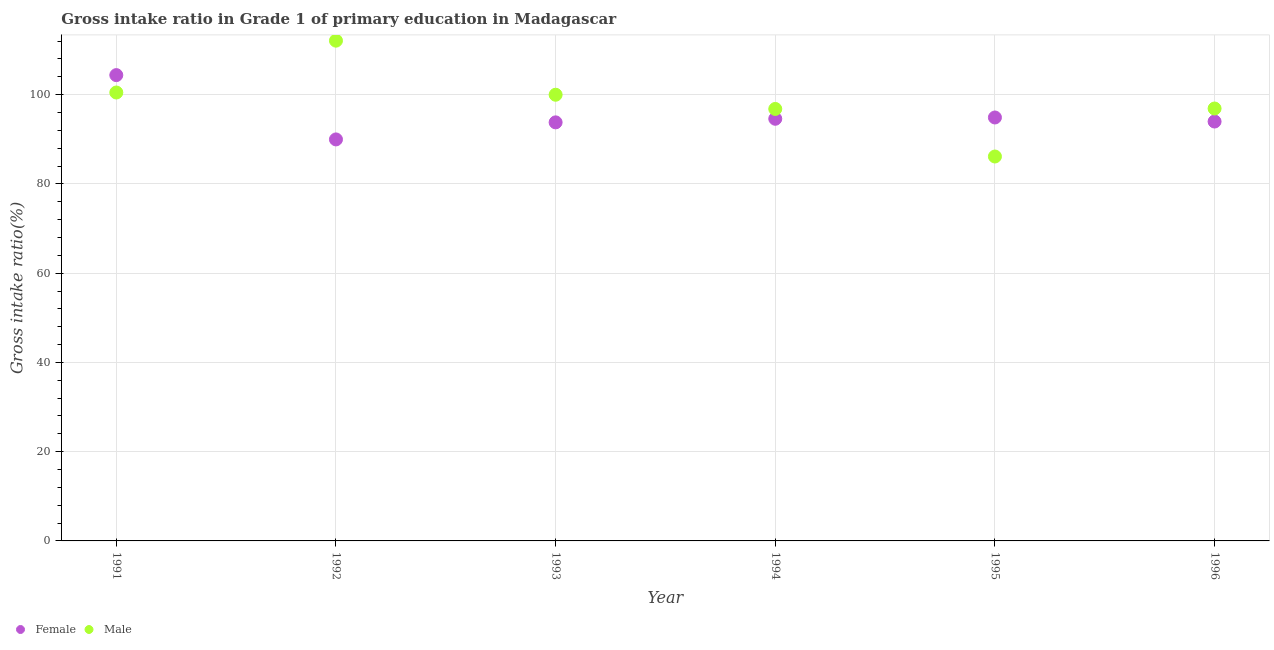How many different coloured dotlines are there?
Offer a very short reply. 2. Is the number of dotlines equal to the number of legend labels?
Offer a very short reply. Yes. What is the gross intake ratio(male) in 1993?
Your answer should be compact. 99.99. Across all years, what is the maximum gross intake ratio(male)?
Offer a very short reply. 112.11. Across all years, what is the minimum gross intake ratio(female)?
Offer a very short reply. 89.98. In which year was the gross intake ratio(male) maximum?
Your answer should be very brief. 1992. In which year was the gross intake ratio(male) minimum?
Give a very brief answer. 1995. What is the total gross intake ratio(male) in the graph?
Provide a short and direct response. 592.44. What is the difference between the gross intake ratio(female) in 1993 and that in 1995?
Give a very brief answer. -1.09. What is the difference between the gross intake ratio(female) in 1991 and the gross intake ratio(male) in 1995?
Provide a succinct answer. 18.24. What is the average gross intake ratio(male) per year?
Give a very brief answer. 98.74. In the year 1996, what is the difference between the gross intake ratio(female) and gross intake ratio(male)?
Your answer should be very brief. -2.92. What is the ratio of the gross intake ratio(female) in 1991 to that in 1996?
Make the answer very short. 1.11. What is the difference between the highest and the second highest gross intake ratio(female)?
Make the answer very short. 9.5. What is the difference between the highest and the lowest gross intake ratio(female)?
Offer a terse response. 14.41. In how many years, is the gross intake ratio(male) greater than the average gross intake ratio(male) taken over all years?
Make the answer very short. 3. Is the gross intake ratio(male) strictly less than the gross intake ratio(female) over the years?
Ensure brevity in your answer.  No. How many years are there in the graph?
Your answer should be compact. 6. What is the difference between two consecutive major ticks on the Y-axis?
Make the answer very short. 20. Does the graph contain grids?
Offer a terse response. Yes. How many legend labels are there?
Give a very brief answer. 2. What is the title of the graph?
Your response must be concise. Gross intake ratio in Grade 1 of primary education in Madagascar. What is the label or title of the X-axis?
Your answer should be very brief. Year. What is the label or title of the Y-axis?
Offer a very short reply. Gross intake ratio(%). What is the Gross intake ratio(%) of Female in 1991?
Provide a succinct answer. 104.39. What is the Gross intake ratio(%) of Male in 1991?
Provide a short and direct response. 100.49. What is the Gross intake ratio(%) in Female in 1992?
Make the answer very short. 89.98. What is the Gross intake ratio(%) in Male in 1992?
Your response must be concise. 112.11. What is the Gross intake ratio(%) in Female in 1993?
Offer a very short reply. 93.8. What is the Gross intake ratio(%) in Male in 1993?
Your answer should be very brief. 99.99. What is the Gross intake ratio(%) of Female in 1994?
Ensure brevity in your answer.  94.6. What is the Gross intake ratio(%) in Male in 1994?
Offer a terse response. 96.8. What is the Gross intake ratio(%) in Female in 1995?
Provide a short and direct response. 94.89. What is the Gross intake ratio(%) of Male in 1995?
Keep it short and to the point. 86.15. What is the Gross intake ratio(%) in Female in 1996?
Ensure brevity in your answer.  93.98. What is the Gross intake ratio(%) of Male in 1996?
Your answer should be very brief. 96.9. Across all years, what is the maximum Gross intake ratio(%) in Female?
Give a very brief answer. 104.39. Across all years, what is the maximum Gross intake ratio(%) of Male?
Your response must be concise. 112.11. Across all years, what is the minimum Gross intake ratio(%) in Female?
Your answer should be compact. 89.98. Across all years, what is the minimum Gross intake ratio(%) of Male?
Give a very brief answer. 86.15. What is the total Gross intake ratio(%) of Female in the graph?
Keep it short and to the point. 571.64. What is the total Gross intake ratio(%) of Male in the graph?
Your answer should be very brief. 592.44. What is the difference between the Gross intake ratio(%) in Female in 1991 and that in 1992?
Your answer should be compact. 14.41. What is the difference between the Gross intake ratio(%) of Male in 1991 and that in 1992?
Offer a terse response. -11.62. What is the difference between the Gross intake ratio(%) in Female in 1991 and that in 1993?
Your response must be concise. 10.59. What is the difference between the Gross intake ratio(%) in Male in 1991 and that in 1993?
Your answer should be compact. 0.5. What is the difference between the Gross intake ratio(%) of Female in 1991 and that in 1994?
Make the answer very short. 9.78. What is the difference between the Gross intake ratio(%) in Male in 1991 and that in 1994?
Offer a very short reply. 3.68. What is the difference between the Gross intake ratio(%) of Female in 1991 and that in 1995?
Your answer should be very brief. 9.49. What is the difference between the Gross intake ratio(%) of Male in 1991 and that in 1995?
Give a very brief answer. 14.34. What is the difference between the Gross intake ratio(%) of Female in 1991 and that in 1996?
Keep it short and to the point. 10.4. What is the difference between the Gross intake ratio(%) in Male in 1991 and that in 1996?
Provide a short and direct response. 3.59. What is the difference between the Gross intake ratio(%) of Female in 1992 and that in 1993?
Your response must be concise. -3.82. What is the difference between the Gross intake ratio(%) of Male in 1992 and that in 1993?
Give a very brief answer. 12.12. What is the difference between the Gross intake ratio(%) of Female in 1992 and that in 1994?
Give a very brief answer. -4.63. What is the difference between the Gross intake ratio(%) of Male in 1992 and that in 1994?
Keep it short and to the point. 15.3. What is the difference between the Gross intake ratio(%) in Female in 1992 and that in 1995?
Keep it short and to the point. -4.92. What is the difference between the Gross intake ratio(%) in Male in 1992 and that in 1995?
Make the answer very short. 25.96. What is the difference between the Gross intake ratio(%) in Female in 1992 and that in 1996?
Your answer should be very brief. -4.01. What is the difference between the Gross intake ratio(%) in Male in 1992 and that in 1996?
Your response must be concise. 15.2. What is the difference between the Gross intake ratio(%) in Female in 1993 and that in 1994?
Ensure brevity in your answer.  -0.8. What is the difference between the Gross intake ratio(%) of Male in 1993 and that in 1994?
Your answer should be compact. 3.18. What is the difference between the Gross intake ratio(%) in Female in 1993 and that in 1995?
Provide a short and direct response. -1.09. What is the difference between the Gross intake ratio(%) in Male in 1993 and that in 1995?
Ensure brevity in your answer.  13.84. What is the difference between the Gross intake ratio(%) of Female in 1993 and that in 1996?
Make the answer very short. -0.19. What is the difference between the Gross intake ratio(%) in Male in 1993 and that in 1996?
Offer a very short reply. 3.09. What is the difference between the Gross intake ratio(%) in Female in 1994 and that in 1995?
Keep it short and to the point. -0.29. What is the difference between the Gross intake ratio(%) in Male in 1994 and that in 1995?
Give a very brief answer. 10.66. What is the difference between the Gross intake ratio(%) of Female in 1994 and that in 1996?
Give a very brief answer. 0.62. What is the difference between the Gross intake ratio(%) in Male in 1994 and that in 1996?
Make the answer very short. -0.1. What is the difference between the Gross intake ratio(%) of Female in 1995 and that in 1996?
Make the answer very short. 0.91. What is the difference between the Gross intake ratio(%) of Male in 1995 and that in 1996?
Your response must be concise. -10.76. What is the difference between the Gross intake ratio(%) of Female in 1991 and the Gross intake ratio(%) of Male in 1992?
Your answer should be compact. -7.72. What is the difference between the Gross intake ratio(%) in Female in 1991 and the Gross intake ratio(%) in Male in 1993?
Offer a terse response. 4.4. What is the difference between the Gross intake ratio(%) of Female in 1991 and the Gross intake ratio(%) of Male in 1994?
Make the answer very short. 7.58. What is the difference between the Gross intake ratio(%) of Female in 1991 and the Gross intake ratio(%) of Male in 1995?
Ensure brevity in your answer.  18.24. What is the difference between the Gross intake ratio(%) of Female in 1991 and the Gross intake ratio(%) of Male in 1996?
Provide a succinct answer. 7.48. What is the difference between the Gross intake ratio(%) in Female in 1992 and the Gross intake ratio(%) in Male in 1993?
Your response must be concise. -10.01. What is the difference between the Gross intake ratio(%) in Female in 1992 and the Gross intake ratio(%) in Male in 1994?
Provide a short and direct response. -6.83. What is the difference between the Gross intake ratio(%) of Female in 1992 and the Gross intake ratio(%) of Male in 1995?
Provide a short and direct response. 3.83. What is the difference between the Gross intake ratio(%) of Female in 1992 and the Gross intake ratio(%) of Male in 1996?
Give a very brief answer. -6.93. What is the difference between the Gross intake ratio(%) of Female in 1993 and the Gross intake ratio(%) of Male in 1994?
Give a very brief answer. -3.01. What is the difference between the Gross intake ratio(%) of Female in 1993 and the Gross intake ratio(%) of Male in 1995?
Offer a terse response. 7.65. What is the difference between the Gross intake ratio(%) in Female in 1993 and the Gross intake ratio(%) in Male in 1996?
Provide a succinct answer. -3.1. What is the difference between the Gross intake ratio(%) in Female in 1994 and the Gross intake ratio(%) in Male in 1995?
Your answer should be compact. 8.46. What is the difference between the Gross intake ratio(%) in Female in 1994 and the Gross intake ratio(%) in Male in 1996?
Offer a terse response. -2.3. What is the difference between the Gross intake ratio(%) of Female in 1995 and the Gross intake ratio(%) of Male in 1996?
Provide a short and direct response. -2.01. What is the average Gross intake ratio(%) in Female per year?
Your answer should be compact. 95.27. What is the average Gross intake ratio(%) in Male per year?
Your answer should be compact. 98.74. In the year 1991, what is the difference between the Gross intake ratio(%) of Female and Gross intake ratio(%) of Male?
Keep it short and to the point. 3.9. In the year 1992, what is the difference between the Gross intake ratio(%) of Female and Gross intake ratio(%) of Male?
Provide a succinct answer. -22.13. In the year 1993, what is the difference between the Gross intake ratio(%) in Female and Gross intake ratio(%) in Male?
Offer a very short reply. -6.19. In the year 1994, what is the difference between the Gross intake ratio(%) of Female and Gross intake ratio(%) of Male?
Give a very brief answer. -2.2. In the year 1995, what is the difference between the Gross intake ratio(%) of Female and Gross intake ratio(%) of Male?
Provide a short and direct response. 8.75. In the year 1996, what is the difference between the Gross intake ratio(%) in Female and Gross intake ratio(%) in Male?
Your answer should be very brief. -2.92. What is the ratio of the Gross intake ratio(%) in Female in 1991 to that in 1992?
Give a very brief answer. 1.16. What is the ratio of the Gross intake ratio(%) in Male in 1991 to that in 1992?
Make the answer very short. 0.9. What is the ratio of the Gross intake ratio(%) of Female in 1991 to that in 1993?
Provide a succinct answer. 1.11. What is the ratio of the Gross intake ratio(%) in Female in 1991 to that in 1994?
Your answer should be compact. 1.1. What is the ratio of the Gross intake ratio(%) of Male in 1991 to that in 1994?
Your answer should be compact. 1.04. What is the ratio of the Gross intake ratio(%) of Female in 1991 to that in 1995?
Provide a succinct answer. 1.1. What is the ratio of the Gross intake ratio(%) of Male in 1991 to that in 1995?
Offer a very short reply. 1.17. What is the ratio of the Gross intake ratio(%) in Female in 1991 to that in 1996?
Keep it short and to the point. 1.11. What is the ratio of the Gross intake ratio(%) in Female in 1992 to that in 1993?
Give a very brief answer. 0.96. What is the ratio of the Gross intake ratio(%) in Male in 1992 to that in 1993?
Your answer should be very brief. 1.12. What is the ratio of the Gross intake ratio(%) in Female in 1992 to that in 1994?
Your response must be concise. 0.95. What is the ratio of the Gross intake ratio(%) in Male in 1992 to that in 1994?
Make the answer very short. 1.16. What is the ratio of the Gross intake ratio(%) in Female in 1992 to that in 1995?
Your answer should be very brief. 0.95. What is the ratio of the Gross intake ratio(%) in Male in 1992 to that in 1995?
Keep it short and to the point. 1.3. What is the ratio of the Gross intake ratio(%) in Female in 1992 to that in 1996?
Your answer should be compact. 0.96. What is the ratio of the Gross intake ratio(%) of Male in 1992 to that in 1996?
Give a very brief answer. 1.16. What is the ratio of the Gross intake ratio(%) in Male in 1993 to that in 1994?
Offer a very short reply. 1.03. What is the ratio of the Gross intake ratio(%) of Female in 1993 to that in 1995?
Ensure brevity in your answer.  0.99. What is the ratio of the Gross intake ratio(%) of Male in 1993 to that in 1995?
Keep it short and to the point. 1.16. What is the ratio of the Gross intake ratio(%) of Male in 1993 to that in 1996?
Ensure brevity in your answer.  1.03. What is the ratio of the Gross intake ratio(%) in Male in 1994 to that in 1995?
Make the answer very short. 1.12. What is the ratio of the Gross intake ratio(%) of Female in 1994 to that in 1996?
Offer a terse response. 1.01. What is the ratio of the Gross intake ratio(%) of Male in 1994 to that in 1996?
Give a very brief answer. 1. What is the ratio of the Gross intake ratio(%) in Female in 1995 to that in 1996?
Ensure brevity in your answer.  1.01. What is the ratio of the Gross intake ratio(%) in Male in 1995 to that in 1996?
Provide a succinct answer. 0.89. What is the difference between the highest and the second highest Gross intake ratio(%) in Female?
Your answer should be compact. 9.49. What is the difference between the highest and the second highest Gross intake ratio(%) in Male?
Provide a short and direct response. 11.62. What is the difference between the highest and the lowest Gross intake ratio(%) in Female?
Offer a terse response. 14.41. What is the difference between the highest and the lowest Gross intake ratio(%) in Male?
Make the answer very short. 25.96. 